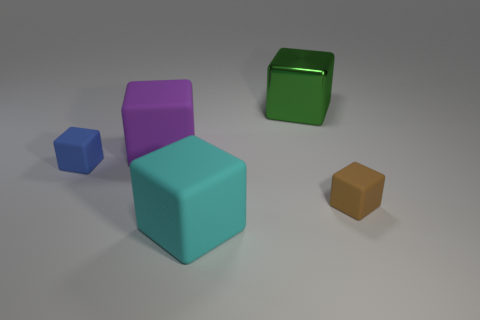Subtract all purple cubes. How many cubes are left? 4 Add 2 brown objects. How many objects exist? 7 Subtract all cyan blocks. How many blocks are left? 4 Subtract 3 blocks. How many blocks are left? 2 Subtract all tiny blue matte blocks. Subtract all large yellow metal cubes. How many objects are left? 4 Add 4 brown rubber blocks. How many brown rubber blocks are left? 5 Add 5 purple rubber things. How many purple rubber things exist? 6 Subtract 0 green cylinders. How many objects are left? 5 Subtract all yellow blocks. Subtract all blue balls. How many blocks are left? 5 Subtract all cyan cylinders. How many cyan blocks are left? 1 